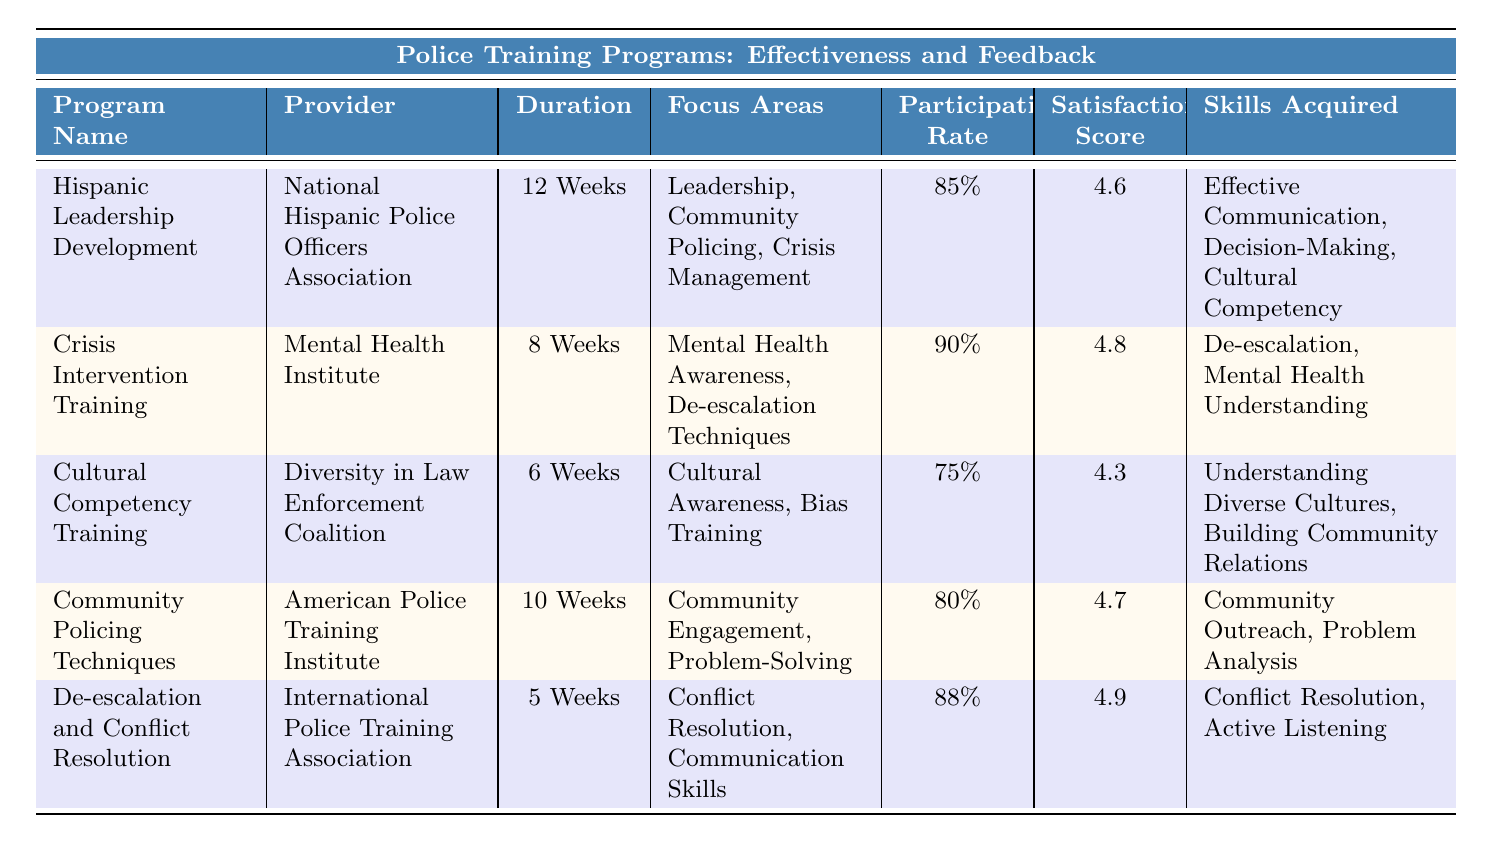What is the highest satisfaction score among the training programs? The satisfaction scores provided for each program are 4.6, 4.8, 4.3, 4.7, and 4.9. The highest score is 4.9, which belongs to the "De-escalation and Conflict Resolution" program.
Answer: 4.9 Which program has the longest duration? The programs and their durations are as follows: "Hispanic Leadership Development" (12 weeks), "Community Policing Techniques" (10 weeks), "Crisis Intervention Training" (8 weeks), "Cultural Competency Training" (6 weeks), and "De-escalation and Conflict Resolution" (5 weeks). The longest duration is 12 weeks.
Answer: 12 Weeks What percentage of participants were satisfied with the "Crisis Intervention Training"? The satisfaction score for "Crisis Intervention Training" is 4.8. Since no explicit percentage of satisfaction is given, we can consider this score as representative of high satisfaction among participants.
Answer: 4.8 Which two programs have a satisfaction score of 4.6 or higher? The programs with satisfaction scores of 4.6 or higher are "Hispanic Leadership Development" (4.6), "Crisis Intervention Training" (4.8), "Community Policing Techniques" (4.7), and "De-escalation and Conflict Resolution" (4.9). The two programs with the lowest scores above 4.6 are "Hispanic Leadership Development" and "Community Policing Techniques".
Answer: Hispanic Leadership Development and Community Policing Techniques What is the average participation rate of the training programs? The participation rates are 85%, 90%, 75%, 80%, and 88%. To find the average, sum them up: 85 + 90 + 75 + 80 + 88 = 418. Divide by the number of programs (5): 418/5 = 83.6.
Answer: 83.6% Is the "Cultural Competency Training" program less effective than the "Community Policing Techniques" program based on participant feedback? The satisfaction score for "Cultural Competency Training" is 4.3, while for "Community Policing Techniques" it is 4.7. Since a lower score indicates lower effectiveness in participant feedback, yes, it is less effective.
Answer: Yes Among the programs provided, how many have a participation rate of 85% or higher? The participation rates listed are 85%, 90%, 75%, 80%, and 88%. The programs with participation rates of 85% or higher are "Hispanic Leadership Development," "Crisis Intervention Training," and "De-escalation and Conflict Resolution," totaling three programs.
Answer: 3 What improvement suggestion was consistently mentioned across more than one program? Each program has unique suggestions, but both "Crisis Intervention Training" and "De-escalation and Conflict Resolution" suggest incorporating more practical scenarios (role-playing and scenarios practiced), indicating a need for hands-on experience.
Answer: More Practical Scenarios How does the focus area of "Crisis Intervention Training" primarily differ from "Cultural Competency Training"? "Crisis Intervention Training" focuses on mental health awareness and de-escalation techniques. In contrast, "Cultural Competency Training" concentrates on cultural awareness and bias training. Therefore, they differ in the context of their focus areas.
Answer: They focus on different areas: mental health vs. cultural awareness 